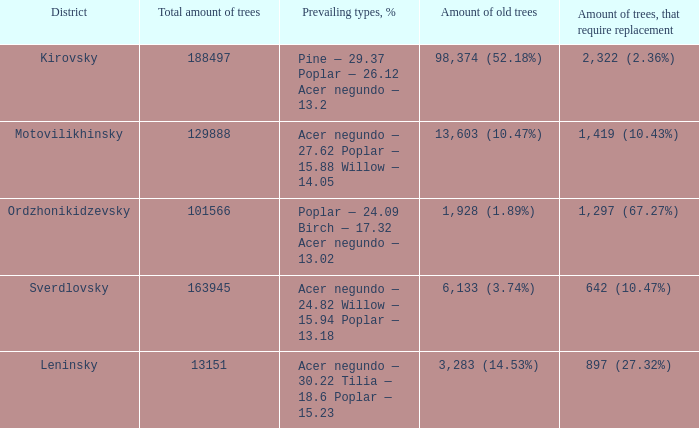22 tilia — 1 Leninsky. 